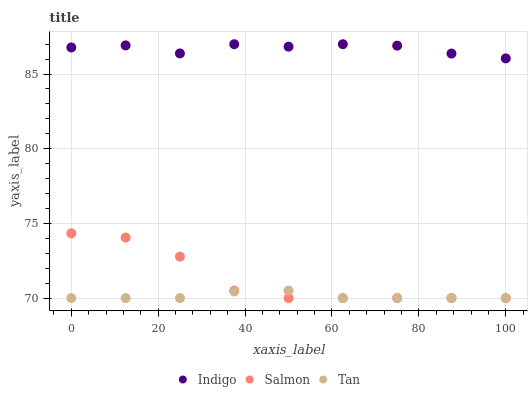Does Tan have the minimum area under the curve?
Answer yes or no. Yes. Does Indigo have the maximum area under the curve?
Answer yes or no. Yes. Does Indigo have the minimum area under the curve?
Answer yes or no. No. Does Tan have the maximum area under the curve?
Answer yes or no. No. Is Tan the smoothest?
Answer yes or no. Yes. Is Salmon the roughest?
Answer yes or no. Yes. Is Indigo the smoothest?
Answer yes or no. No. Is Indigo the roughest?
Answer yes or no. No. Does Salmon have the lowest value?
Answer yes or no. Yes. Does Indigo have the lowest value?
Answer yes or no. No. Does Indigo have the highest value?
Answer yes or no. Yes. Does Tan have the highest value?
Answer yes or no. No. Is Salmon less than Indigo?
Answer yes or no. Yes. Is Indigo greater than Tan?
Answer yes or no. Yes. Does Salmon intersect Tan?
Answer yes or no. Yes. Is Salmon less than Tan?
Answer yes or no. No. Is Salmon greater than Tan?
Answer yes or no. No. Does Salmon intersect Indigo?
Answer yes or no. No. 